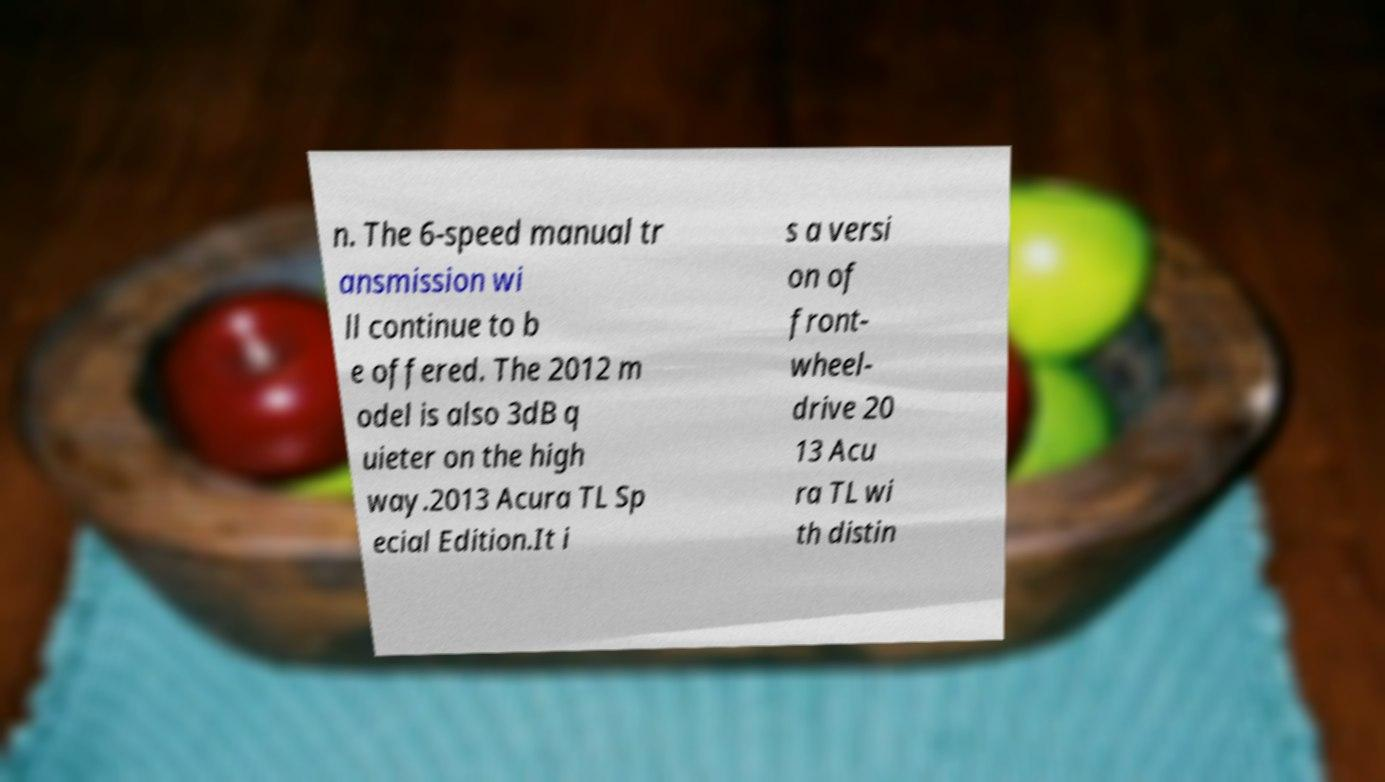What messages or text are displayed in this image? I need them in a readable, typed format. n. The 6-speed manual tr ansmission wi ll continue to b e offered. The 2012 m odel is also 3dB q uieter on the high way.2013 Acura TL Sp ecial Edition.It i s a versi on of front- wheel- drive 20 13 Acu ra TL wi th distin 